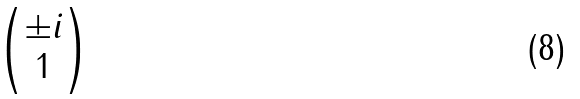<formula> <loc_0><loc_0><loc_500><loc_500>\begin{pmatrix} \pm i \\ 1 \end{pmatrix}</formula> 